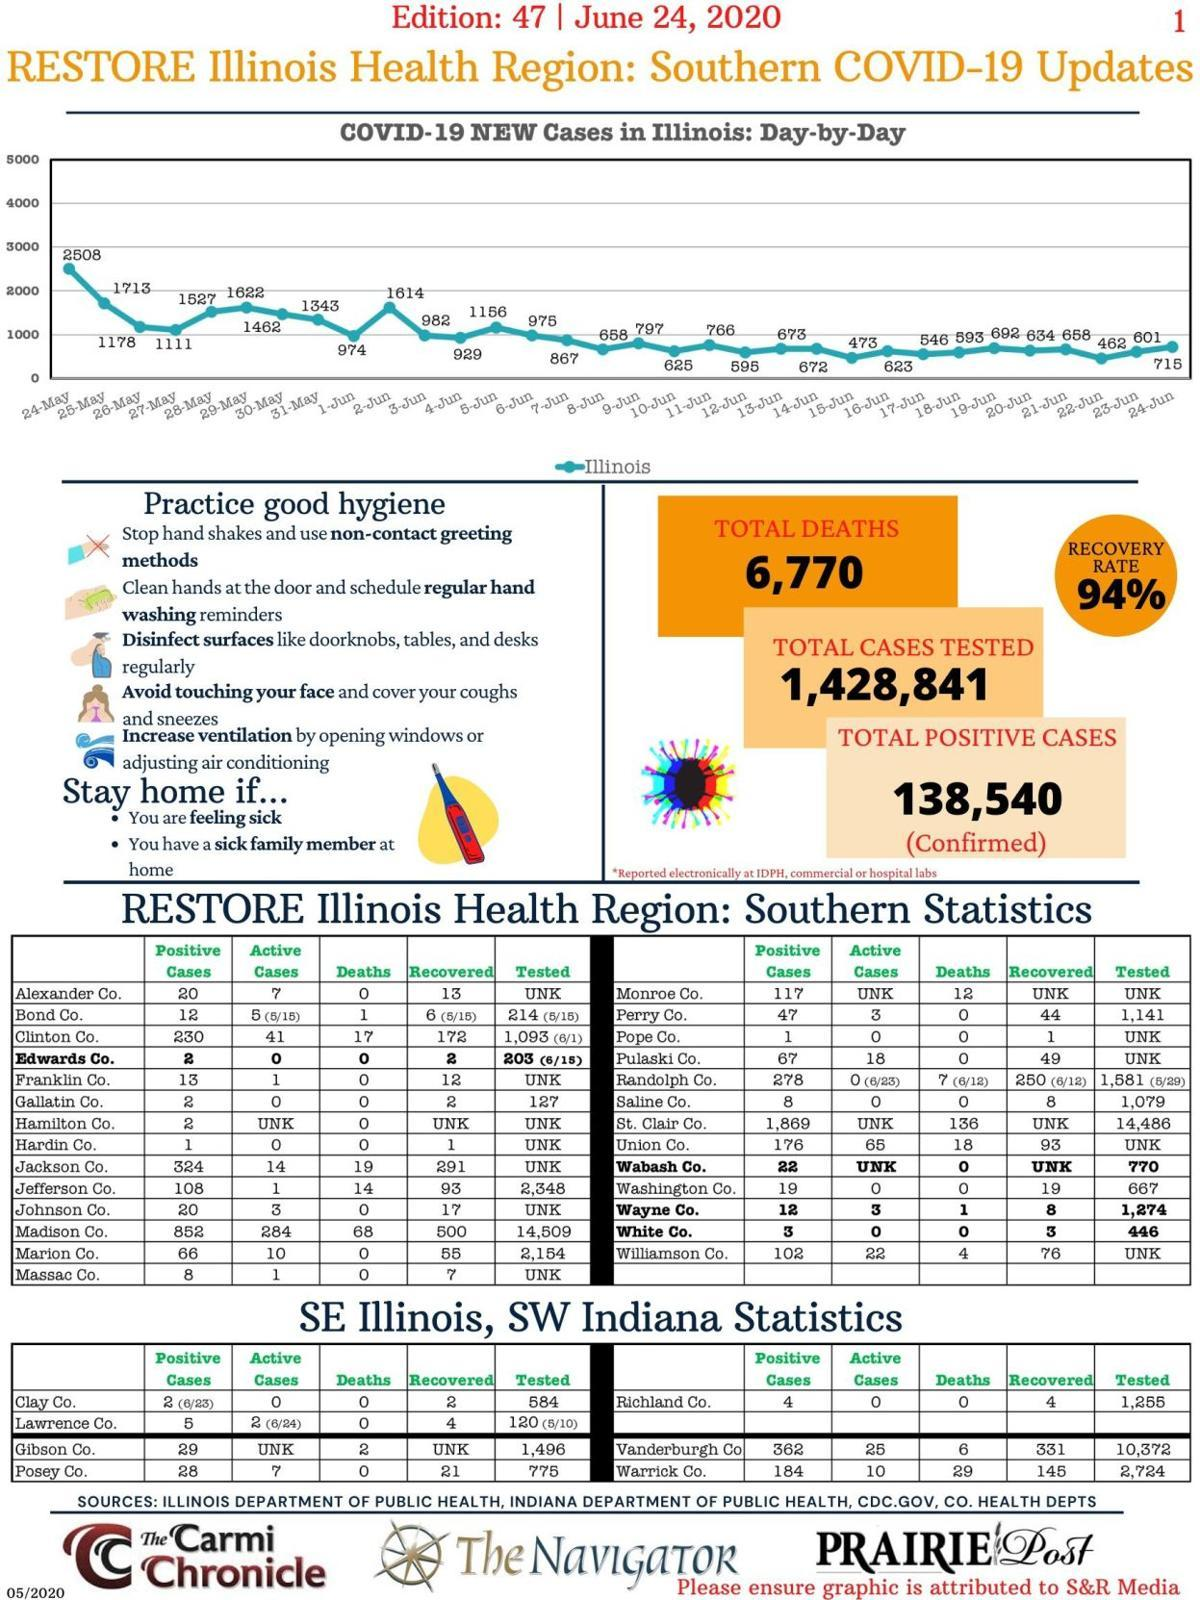Highlight a few significant elements in this photo. The total number of positive cases in Bond Co. and Massac Co., taken together, is 20. There are 1,290,301 total negative cases. The total number of active cases in Jackson County and Johnson County, taken together, is 17. On the 23rd and 24th of June, there were a total of 1316 cases. The total number of active cases in Clay County and Posey County, taken together, is 7. 